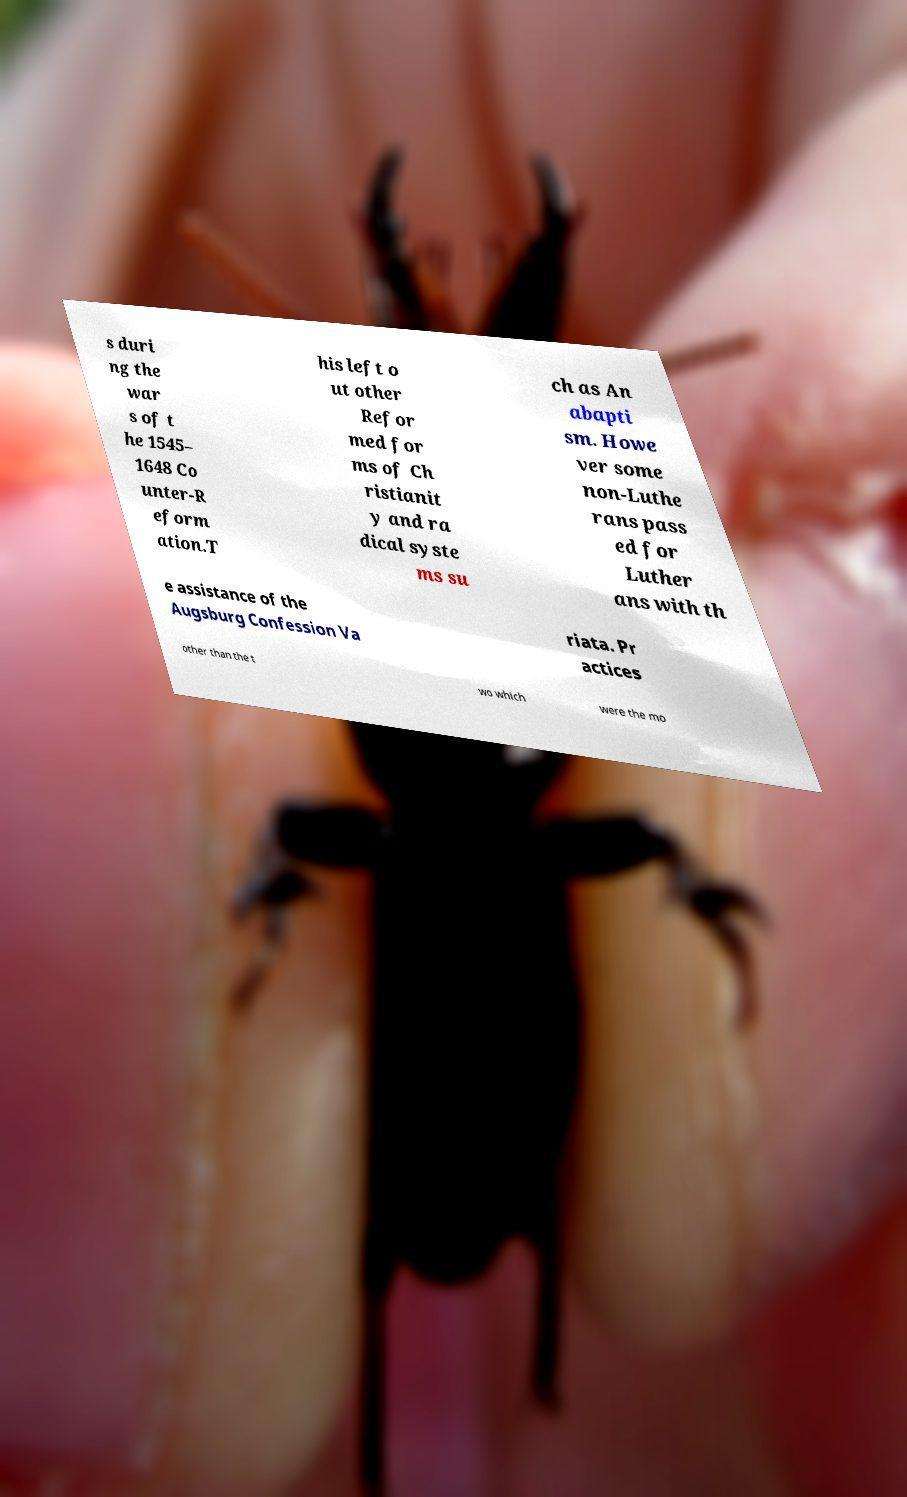I need the written content from this picture converted into text. Can you do that? s duri ng the war s of t he 1545– 1648 Co unter-R eform ation.T his left o ut other Refor med for ms of Ch ristianit y and ra dical syste ms su ch as An abapti sm. Howe ver some non-Luthe rans pass ed for Luther ans with th e assistance of the Augsburg Confession Va riata. Pr actices other than the t wo which were the mo 